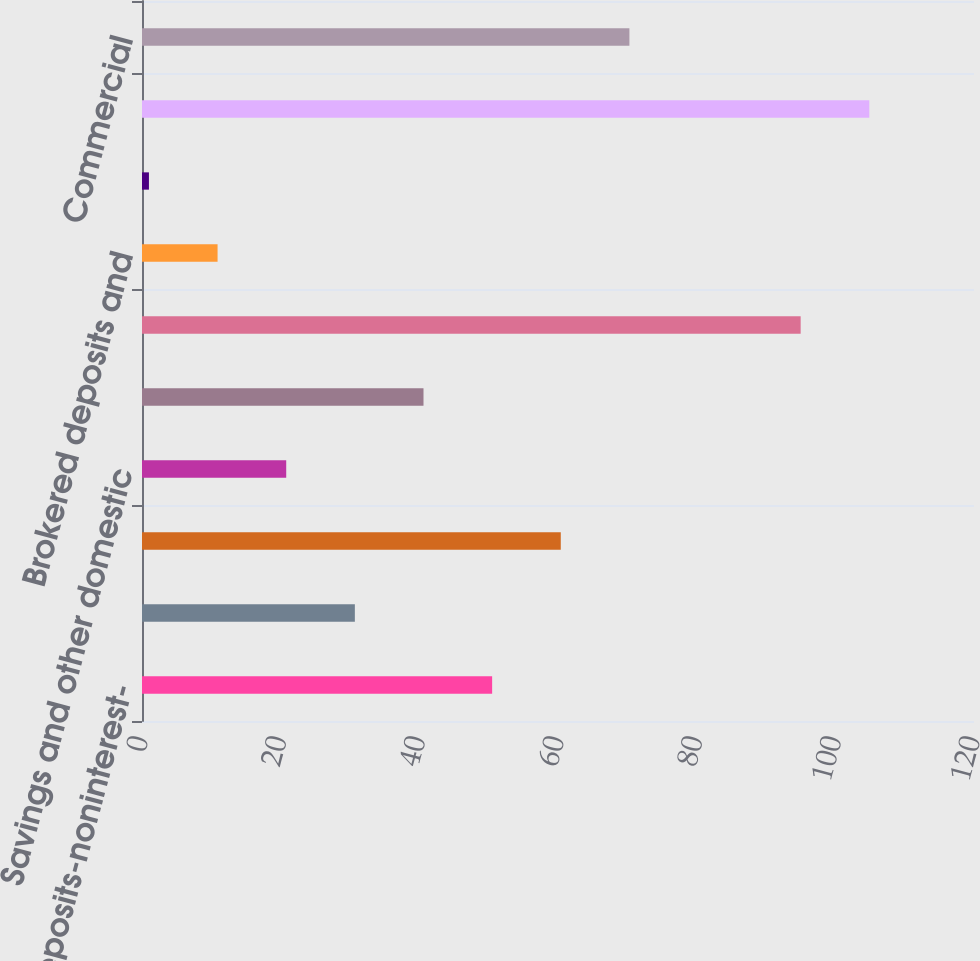<chart> <loc_0><loc_0><loc_500><loc_500><bar_chart><fcel>Demand deposits-noninterest-<fcel>Demand<fcel>Money market deposits<fcel>Savings and other domestic<fcel>Core certificates of deposit<fcel>Total core deposits<fcel>Brokered deposits and<fcel>Deposits in foreign offices<fcel>Total deposits<fcel>Commercial<nl><fcel>50.5<fcel>30.7<fcel>60.4<fcel>20.8<fcel>40.6<fcel>95<fcel>10.9<fcel>1<fcel>104.9<fcel>70.3<nl></chart> 